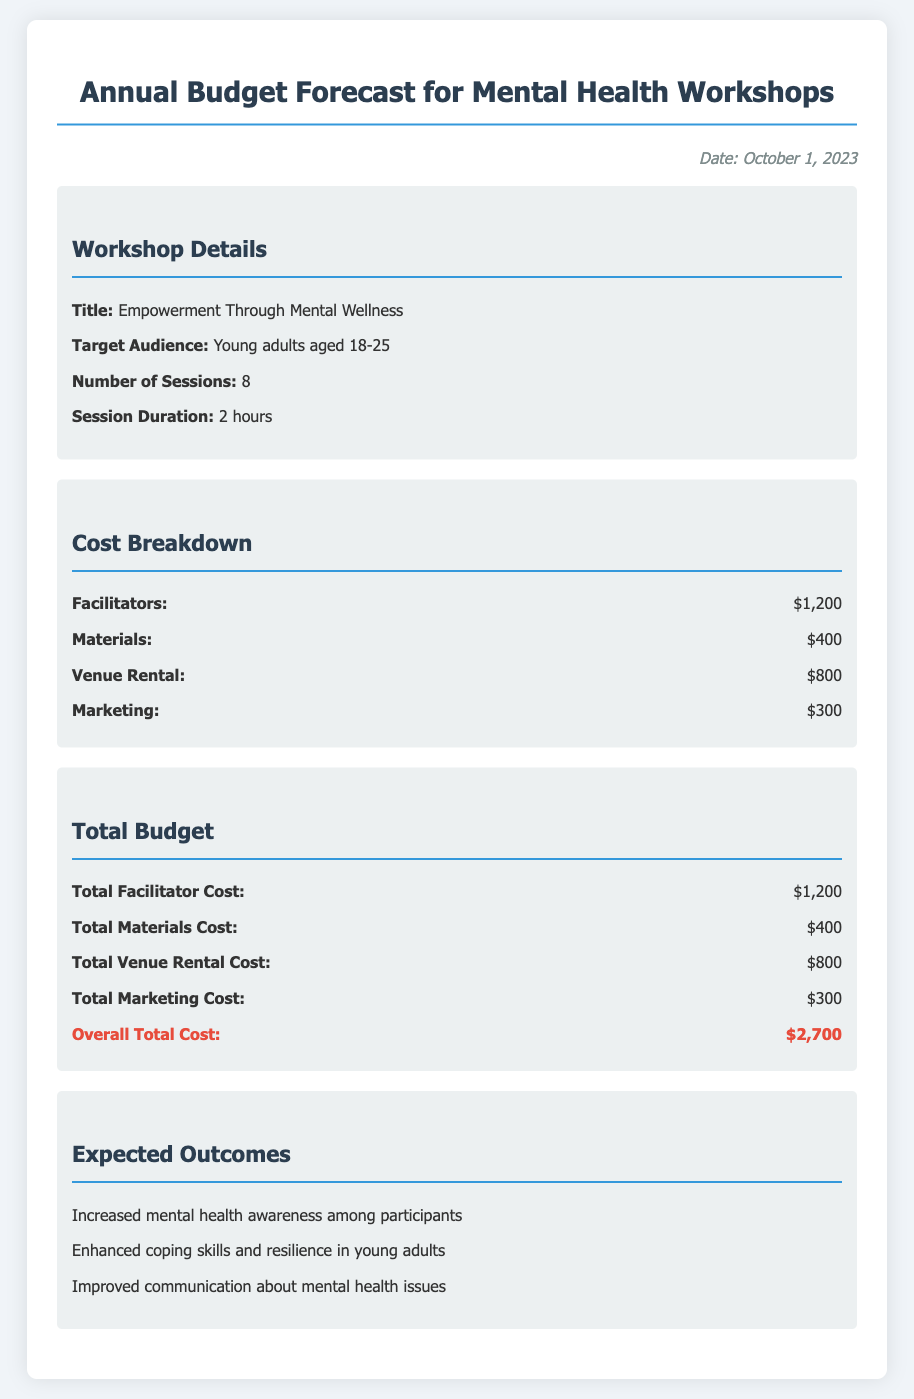What is the total budget for the workshops? The overall total cost is listed in the document, which combines all expenses related to the workshops.
Answer: $2,700 What is the target audience for the workshops? The document specifies the group that the workshops are designed for, which is mentioned under workshop details.
Answer: Young adults aged 18-25 How many sessions are planned for the workshops? This information is included in the workshop details section of the document.
Answer: 8 What is the cost for materials? The cost for materials is explicitly stated in the cost breakdown section of the document.
Answer: $400 What is the total facilitator cost? The document provides the total amount for hiring facilitators within the total budget section.
Answer: $1,200 What is the venue rental fee? The document outlines the expenses specifically for venue rental in the cost breakdown section.
Answer: $800 What are the expected outcomes listed in the document? This information reflects what the workshops aim to achieve, which is mentioned in the expected outcomes section.
Answer: Increased mental health awareness among participants What is the duration of each session? The duration of the sessions is specified in the workshop details section of the document.
Answer: 2 hours How much is allocated for marketing? Marketing costs are detailed within the cost breakdown section of the document.
Answer: $300 